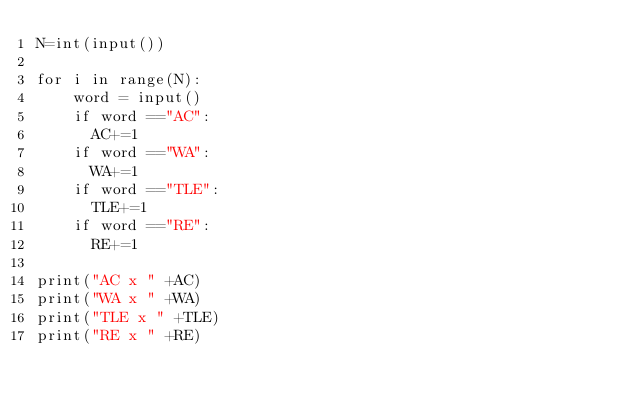Convert code to text. <code><loc_0><loc_0><loc_500><loc_500><_Python_>N=int(input())

for i in range(N):
	word = input()
    if word =="AC":
      AC+=1
    if word =="WA":
      WA+=1
    if word =="TLE":
      TLE+=1
    if word =="RE":
      RE+=1

print("AC x " +AC)
print("WA x " +WA)
print("TLE x " +TLE)
print("RE x " +RE)</code> 